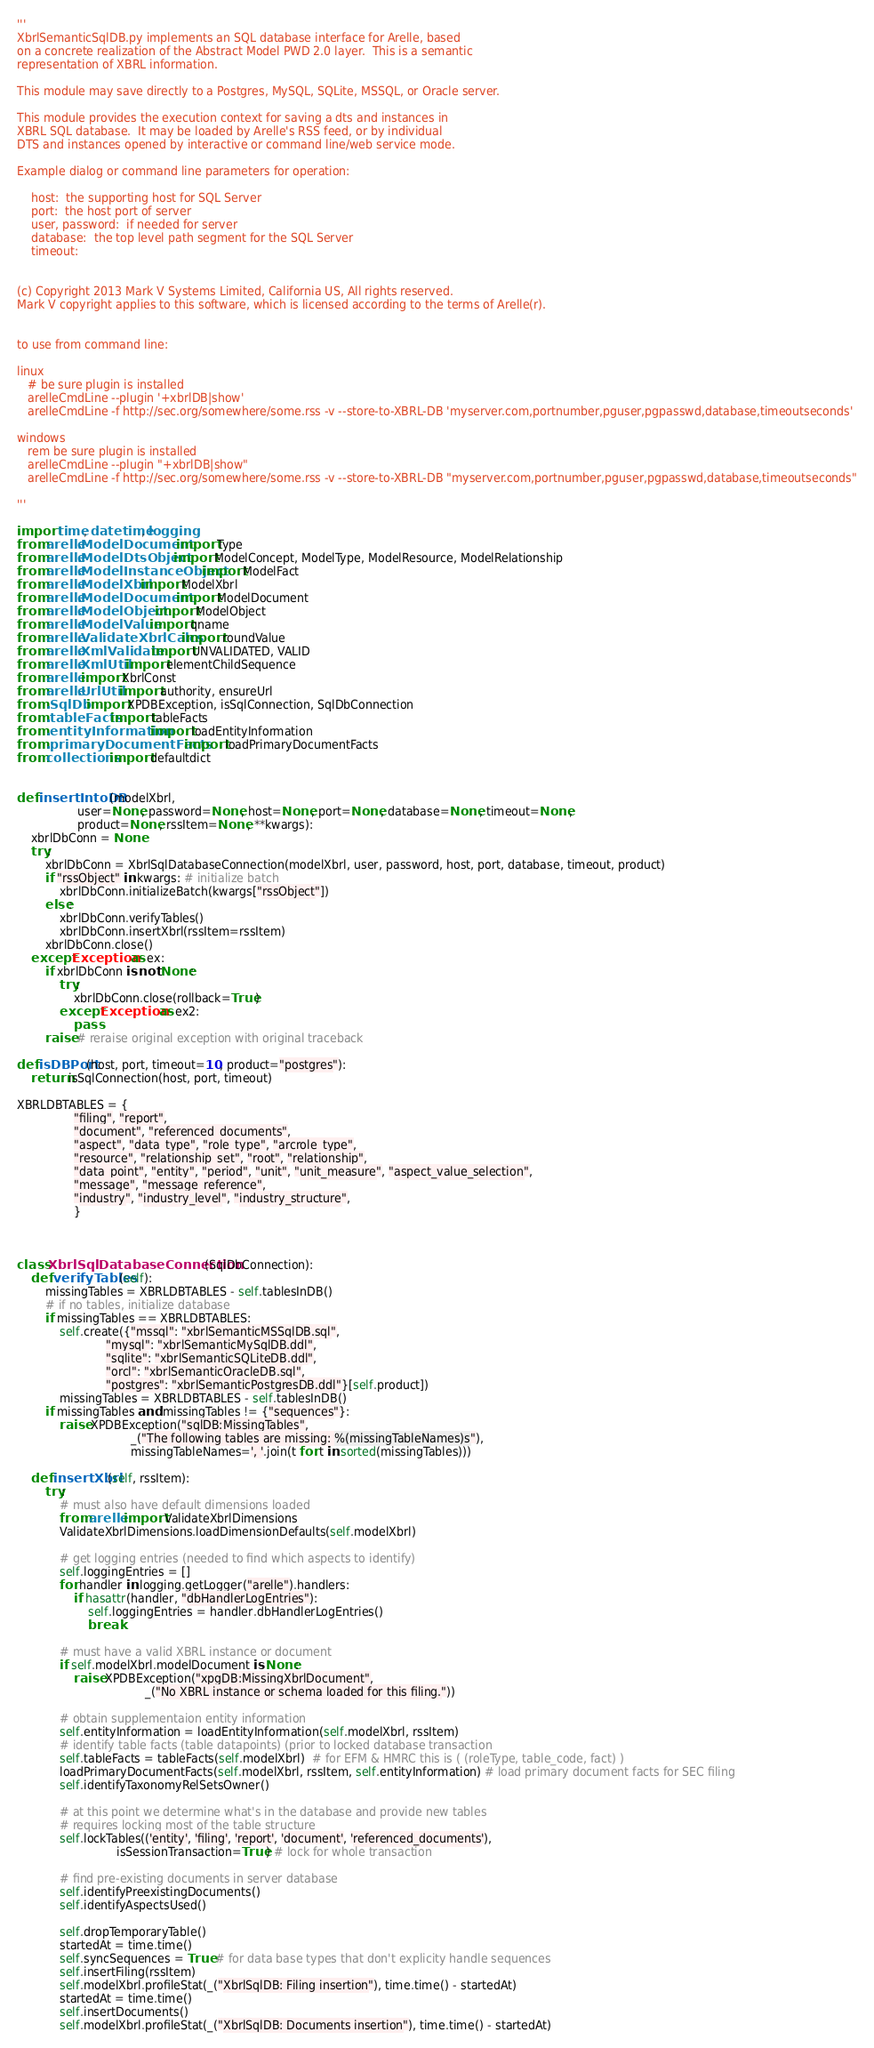Convert code to text. <code><loc_0><loc_0><loc_500><loc_500><_Python_>'''
XbrlSemanticSqlDB.py implements an SQL database interface for Arelle, based
on a concrete realization of the Abstract Model PWD 2.0 layer.  This is a semantic 
representation of XBRL information. 

This module may save directly to a Postgres, MySQL, SQLite, MSSQL, or Oracle server.

This module provides the execution context for saving a dts and instances in 
XBRL SQL database.  It may be loaded by Arelle's RSS feed, or by individual
DTS and instances opened by interactive or command line/web service mode.

Example dialog or command line parameters for operation:

    host:  the supporting host for SQL Server
    port:  the host port of server
    user, password:  if needed for server
    database:  the top level path segment for the SQL Server
    timeout: 
    

(c) Copyright 2013 Mark V Systems Limited, California US, All rights reserved.  
Mark V copyright applies to this software, which is licensed according to the terms of Arelle(r).


to use from command line:

linux
   # be sure plugin is installed
   arelleCmdLine --plugin '+xbrlDB|show'
   arelleCmdLine -f http://sec.org/somewhere/some.rss -v --store-to-XBRL-DB 'myserver.com,portnumber,pguser,pgpasswd,database,timeoutseconds'
   
windows
   rem be sure plugin is installed
   arelleCmdLine --plugin "+xbrlDB|show"
   arelleCmdLine -f http://sec.org/somewhere/some.rss -v --store-to-XBRL-DB "myserver.com,portnumber,pguser,pgpasswd,database,timeoutseconds"

'''

import time, datetime, logging
from arelle.ModelDocument import Type
from arelle.ModelDtsObject import ModelConcept, ModelType, ModelResource, ModelRelationship
from arelle.ModelInstanceObject import ModelFact
from arelle.ModelXbrl import ModelXbrl
from arelle.ModelDocument import ModelDocument
from arelle.ModelObject import ModelObject
from arelle.ModelValue import qname
from arelle.ValidateXbrlCalcs import roundValue
from arelle.XmlValidate import UNVALIDATED, VALID
from arelle.XmlUtil import elementChildSequence
from arelle import XbrlConst
from arelle.UrlUtil import authority, ensureUrl
from .SqlDb import XPDBException, isSqlConnection, SqlDbConnection
from .tableFacts import tableFacts
from .entityInformation import loadEntityInformation
from .primaryDocumentFacts import loadPrimaryDocumentFacts
from collections import defaultdict


def insertIntoDB(modelXbrl, 
                 user=None, password=None, host=None, port=None, database=None, timeout=None,
                 product=None, rssItem=None, **kwargs):
    xbrlDbConn = None
    try:
        xbrlDbConn = XbrlSqlDatabaseConnection(modelXbrl, user, password, host, port, database, timeout, product)
        if "rssObject" in kwargs: # initialize batch
            xbrlDbConn.initializeBatch(kwargs["rssObject"])
        else:
            xbrlDbConn.verifyTables()
            xbrlDbConn.insertXbrl(rssItem=rssItem)
        xbrlDbConn.close()
    except Exception as ex:
        if xbrlDbConn is not None:
            try:
                xbrlDbConn.close(rollback=True)
            except Exception as ex2:
                pass
        raise # reraise original exception with original traceback    
        
def isDBPort(host, port, timeout=10, product="postgres"):
    return isSqlConnection(host, port, timeout)

XBRLDBTABLES = {
                "filing", "report",
                "document", "referenced_documents",
                "aspect", "data_type", "role_type", "arcrole_type",
                "resource", "relationship_set", "root", "relationship",
                "data_point", "entity", "period", "unit", "unit_measure", "aspect_value_selection",
                "message", "message_reference",
                "industry", "industry_level", "industry_structure",
                }



class XbrlSqlDatabaseConnection(SqlDbConnection):
    def verifyTables(self):
        missingTables = XBRLDBTABLES - self.tablesInDB()
        # if no tables, initialize database
        if missingTables == XBRLDBTABLES:
            self.create({"mssql": "xbrlSemanticMSSqlDB.sql",
                         "mysql": "xbrlSemanticMySqlDB.ddl",
                         "sqlite": "xbrlSemanticSQLiteDB.ddl",
                         "orcl": "xbrlSemanticOracleDB.sql",
                         "postgres": "xbrlSemanticPostgresDB.ddl"}[self.product])
            missingTables = XBRLDBTABLES - self.tablesInDB()
        if missingTables and missingTables != {"sequences"}:
            raise XPDBException("sqlDB:MissingTables",
                                _("The following tables are missing: %(missingTableNames)s"),
                                missingTableNames=', '.join(t for t in sorted(missingTables))) 
            
    def insertXbrl(self, rssItem):
        try:
            # must also have default dimensions loaded
            from arelle import ValidateXbrlDimensions
            ValidateXbrlDimensions.loadDimensionDefaults(self.modelXbrl)
            
            # get logging entries (needed to find which aspects to identify)
            self.loggingEntries = []
            for handler in logging.getLogger("arelle").handlers:
                if hasattr(handler, "dbHandlerLogEntries"):
                    self.loggingEntries = handler.dbHandlerLogEntries()
                    break
                
            # must have a valid XBRL instance or document
            if self.modelXbrl.modelDocument is None:
                raise XPDBException("xpgDB:MissingXbrlDocument",
                                    _("No XBRL instance or schema loaded for this filing.")) 
            
            # obtain supplementaion entity information
            self.entityInformation = loadEntityInformation(self.modelXbrl, rssItem)
            # identify table facts (table datapoints) (prior to locked database transaction
            self.tableFacts = tableFacts(self.modelXbrl)  # for EFM & HMRC this is ( (roleType, table_code, fact) )
            loadPrimaryDocumentFacts(self.modelXbrl, rssItem, self.entityInformation) # load primary document facts for SEC filing
            self.identifyTaxonomyRelSetsOwner()
                        
            # at this point we determine what's in the database and provide new tables
            # requires locking most of the table structure
            self.lockTables(('entity', 'filing', 'report', 'document', 'referenced_documents'),
                            isSessionTransaction=True) # lock for whole transaction
            
            # find pre-existing documents in server database
            self.identifyPreexistingDocuments()
            self.identifyAspectsUsed()
            
            self.dropTemporaryTable()
            startedAt = time.time()
            self.syncSequences = True # for data base types that don't explicity handle sequences
            self.insertFiling(rssItem)
            self.modelXbrl.profileStat(_("XbrlSqlDB: Filing insertion"), time.time() - startedAt)
            startedAt = time.time()
            self.insertDocuments()
            self.modelXbrl.profileStat(_("XbrlSqlDB: Documents insertion"), time.time() - startedAt)</code> 